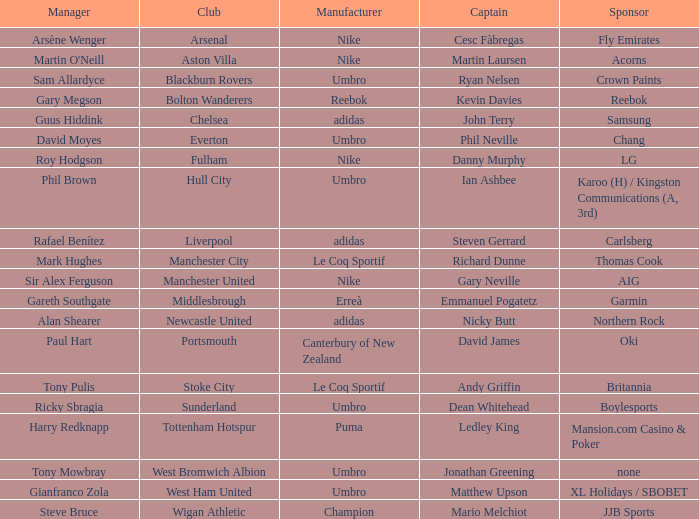Could you parse the entire table? {'header': ['Manager', 'Club', 'Manufacturer', 'Captain', 'Sponsor'], 'rows': [['Arsène Wenger', 'Arsenal', 'Nike', 'Cesc Fàbregas', 'Fly Emirates'], ["Martin O'Neill", 'Aston Villa', 'Nike', 'Martin Laursen', 'Acorns'], ['Sam Allardyce', 'Blackburn Rovers', 'Umbro', 'Ryan Nelsen', 'Crown Paints'], ['Gary Megson', 'Bolton Wanderers', 'Reebok', 'Kevin Davies', 'Reebok'], ['Guus Hiddink', 'Chelsea', 'adidas', 'John Terry', 'Samsung'], ['David Moyes', 'Everton', 'Umbro', 'Phil Neville', 'Chang'], ['Roy Hodgson', 'Fulham', 'Nike', 'Danny Murphy', 'LG'], ['Phil Brown', 'Hull City', 'Umbro', 'Ian Ashbee', 'Karoo (H) / Kingston Communications (A, 3rd)'], ['Rafael Benítez', 'Liverpool', 'adidas', 'Steven Gerrard', 'Carlsberg'], ['Mark Hughes', 'Manchester City', 'Le Coq Sportif', 'Richard Dunne', 'Thomas Cook'], ['Sir Alex Ferguson', 'Manchester United', 'Nike', 'Gary Neville', 'AIG'], ['Gareth Southgate', 'Middlesbrough', 'Erreà', 'Emmanuel Pogatetz', 'Garmin'], ['Alan Shearer', 'Newcastle United', 'adidas', 'Nicky Butt', 'Northern Rock'], ['Paul Hart', 'Portsmouth', 'Canterbury of New Zealand', 'David James', 'Oki'], ['Tony Pulis', 'Stoke City', 'Le Coq Sportif', 'Andy Griffin', 'Britannia'], ['Ricky Sbragia', 'Sunderland', 'Umbro', 'Dean Whitehead', 'Boylesports'], ['Harry Redknapp', 'Tottenham Hotspur', 'Puma', 'Ledley King', 'Mansion.com Casino & Poker'], ['Tony Mowbray', 'West Bromwich Albion', 'Umbro', 'Jonathan Greening', 'none'], ['Gianfranco Zola', 'West Ham United', 'Umbro', 'Matthew Upson', 'XL Holidays / SBOBET'], ['Steve Bruce', 'Wigan Athletic', 'Champion', 'Mario Melchiot', 'JJB Sports']]} In which club is Ledley King a captain? Tottenham Hotspur. 